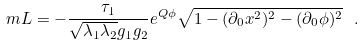Convert formula to latex. <formula><loc_0><loc_0><loc_500><loc_500>\ m L = - \frac { \tau _ { 1 } } { \sqrt { \lambda _ { 1 } \lambda _ { 2 } } g _ { 1 } g _ { 2 } } e ^ { Q \phi } \sqrt { 1 - ( \partial _ { 0 } x ^ { 2 } ) ^ { 2 } - ( \partial _ { 0 } \phi ) ^ { 2 } } \ .</formula> 